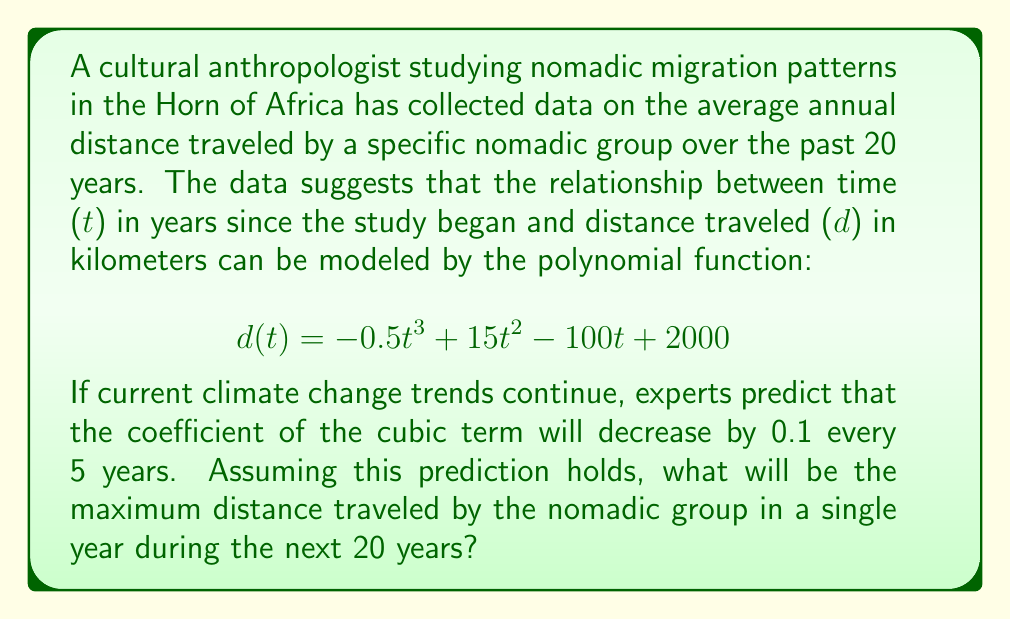Solve this math problem. To solve this problem, we need to follow these steps:

1. Update the polynomial function for the next 20 years:
   The coefficient of the cubic term will change from -0.5 to -0.7 over 20 years.
   New function: $$d(t) = -0.7t^3 + 15t^2 - 100t + 2000$$

2. Find the critical points by taking the derivative and setting it to zero:
   $$d'(t) = -2.1t^2 + 30t - 100$$
   $$-2.1t^2 + 30t - 100 = 0$$

3. Solve the quadratic equation:
   Using the quadratic formula: $t = \frac{-b \pm \sqrt{b^2 - 4ac}}{2a}$
   $$t = \frac{-30 \pm \sqrt{30^2 - 4(-2.1)(-100)}}{2(-2.1)}$$
   $$t = \frac{-30 \pm \sqrt{900 - 840}}{-4.2}$$
   $$t = \frac{-30 \pm \sqrt{60}}{-4.2}$$
   $$t \approx 9.47 \text{ or } 4.77$$

4. Evaluate the function at these critical points and at the endpoints (t = 0 and t = 20):
   $$d(0) = 2000$$
   $$d(4.77) \approx 2180.95$$
   $$d(9.47) \approx 2223.36$$
   $$d(20) \approx 1000$$

5. Compare the values to find the maximum distance traveled.
Answer: The maximum distance traveled by the nomadic group in a single year during the next 20 years will be approximately 2223.36 kilometers, occurring around 9.47 years into the future. 